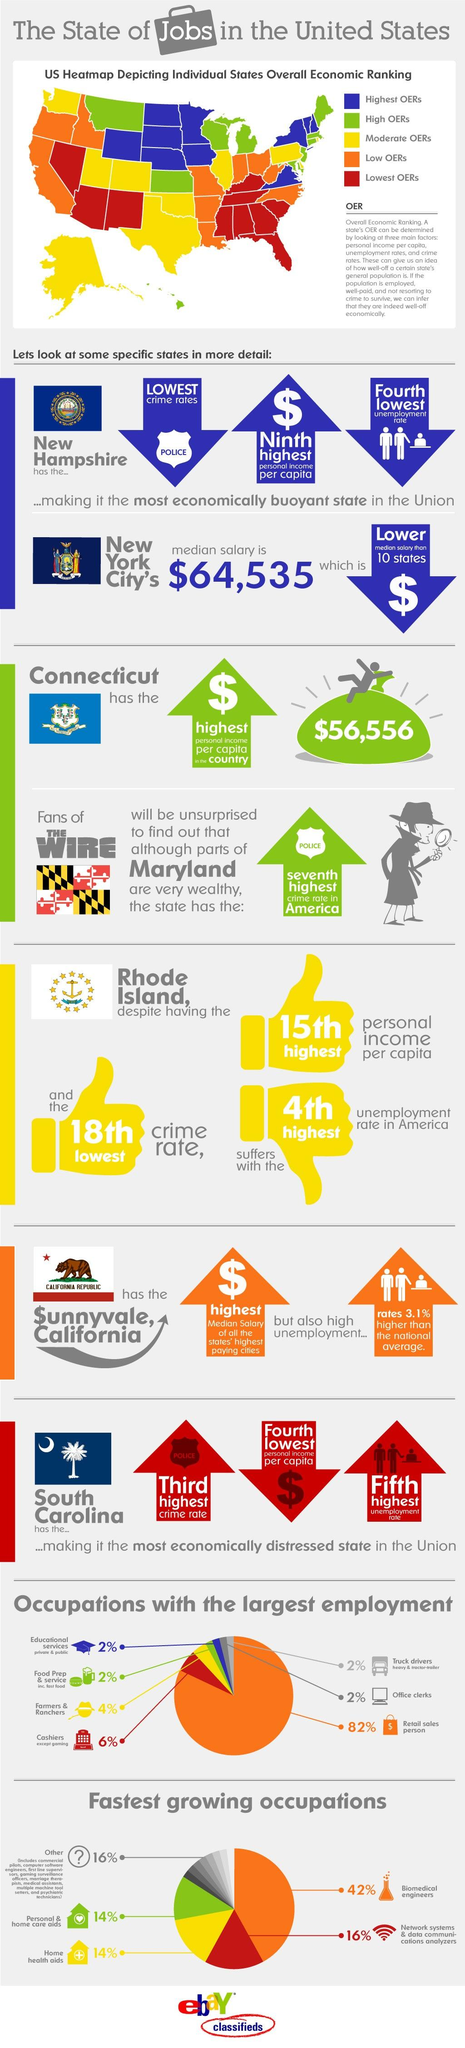Mention a couple of crucial points in this snapshot. In the United States, there are no specific occupations with an employment rate that is equal to 2%. There are 10 states in the USA that have low OERs. The overall economic ranking of the centermost island in the infographic is high. There are 10 states in the USA that have the lowest OERs (operating expenses ratio). The occupation that ranks second in terms of employment is cashiers, except for those in the gaming industry. 